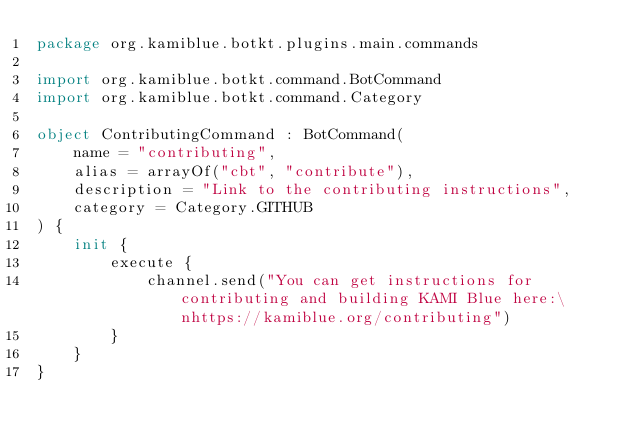Convert code to text. <code><loc_0><loc_0><loc_500><loc_500><_Kotlin_>package org.kamiblue.botkt.plugins.main.commands

import org.kamiblue.botkt.command.BotCommand
import org.kamiblue.botkt.command.Category

object ContributingCommand : BotCommand(
    name = "contributing",
    alias = arrayOf("cbt", "contribute"),
    description = "Link to the contributing instructions",
    category = Category.GITHUB
) {
    init {
        execute {
            channel.send("You can get instructions for contributing and building KAMI Blue here:\nhttps://kamiblue.org/contributing")
        }
    }
}
</code> 